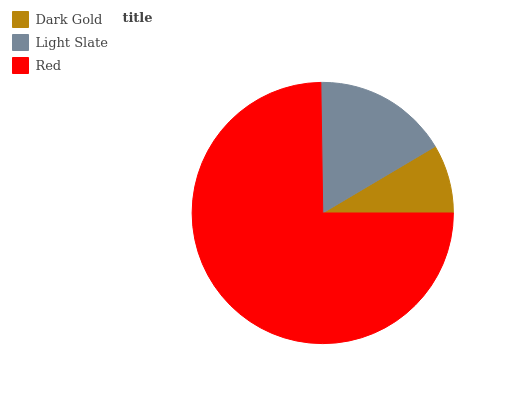Is Dark Gold the minimum?
Answer yes or no. Yes. Is Red the maximum?
Answer yes or no. Yes. Is Light Slate the minimum?
Answer yes or no. No. Is Light Slate the maximum?
Answer yes or no. No. Is Light Slate greater than Dark Gold?
Answer yes or no. Yes. Is Dark Gold less than Light Slate?
Answer yes or no. Yes. Is Dark Gold greater than Light Slate?
Answer yes or no. No. Is Light Slate less than Dark Gold?
Answer yes or no. No. Is Light Slate the high median?
Answer yes or no. Yes. Is Light Slate the low median?
Answer yes or no. Yes. Is Dark Gold the high median?
Answer yes or no. No. Is Dark Gold the low median?
Answer yes or no. No. 